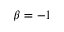<formula> <loc_0><loc_0><loc_500><loc_500>\beta = - 1</formula> 